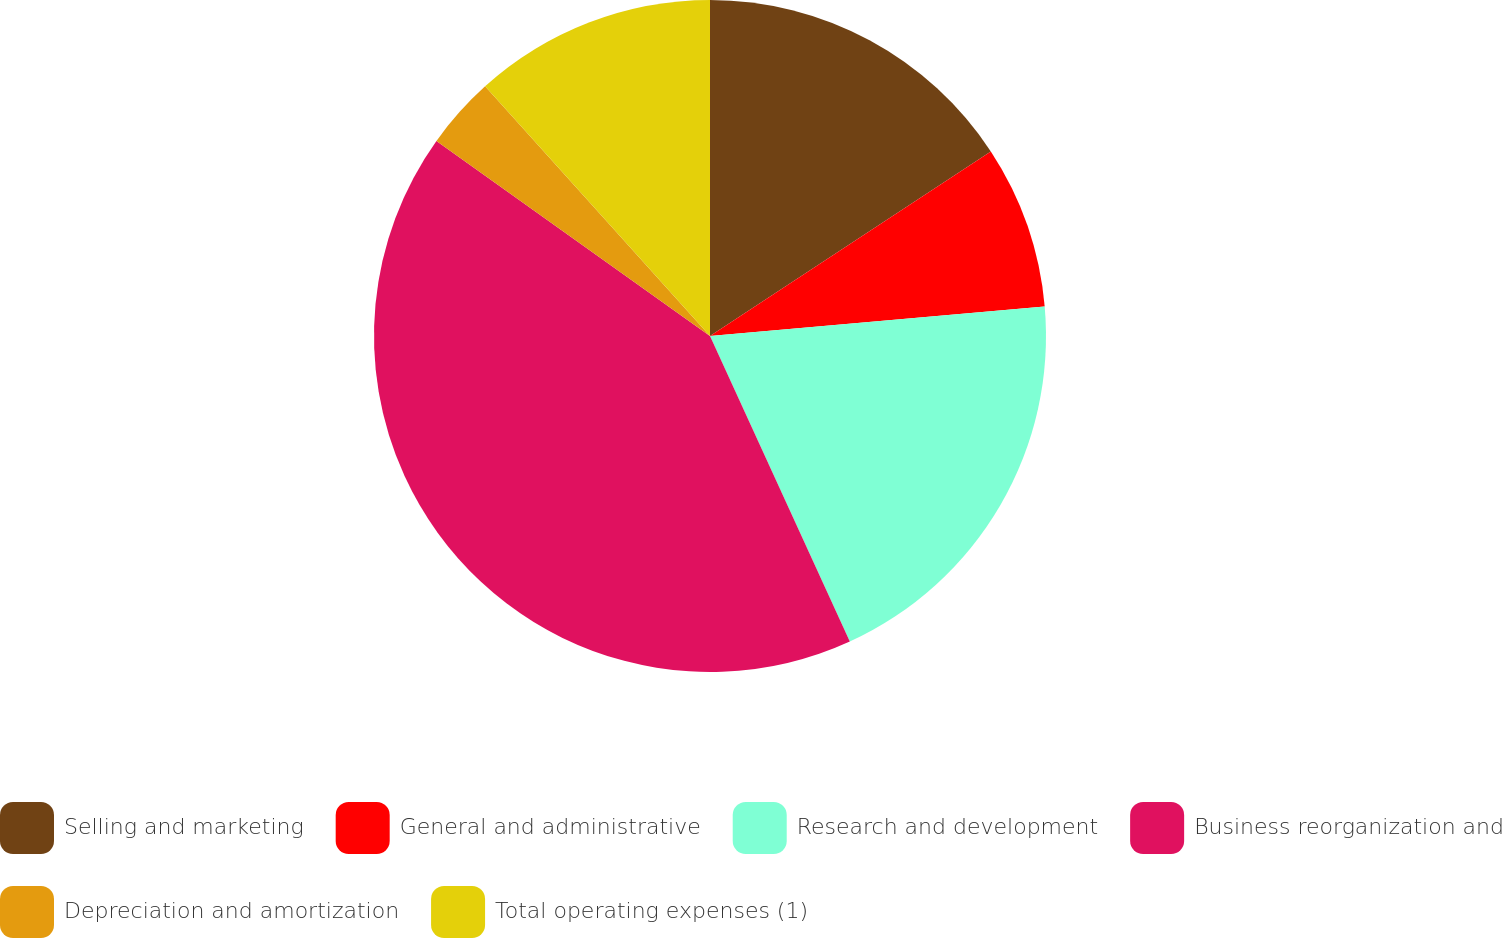Convert chart to OTSL. <chart><loc_0><loc_0><loc_500><loc_500><pie_chart><fcel>Selling and marketing<fcel>General and administrative<fcel>Research and development<fcel>Business reorganization and<fcel>Depreciation and amortization<fcel>Total operating expenses (1)<nl><fcel>15.75%<fcel>7.85%<fcel>19.57%<fcel>41.69%<fcel>3.47%<fcel>11.67%<nl></chart> 